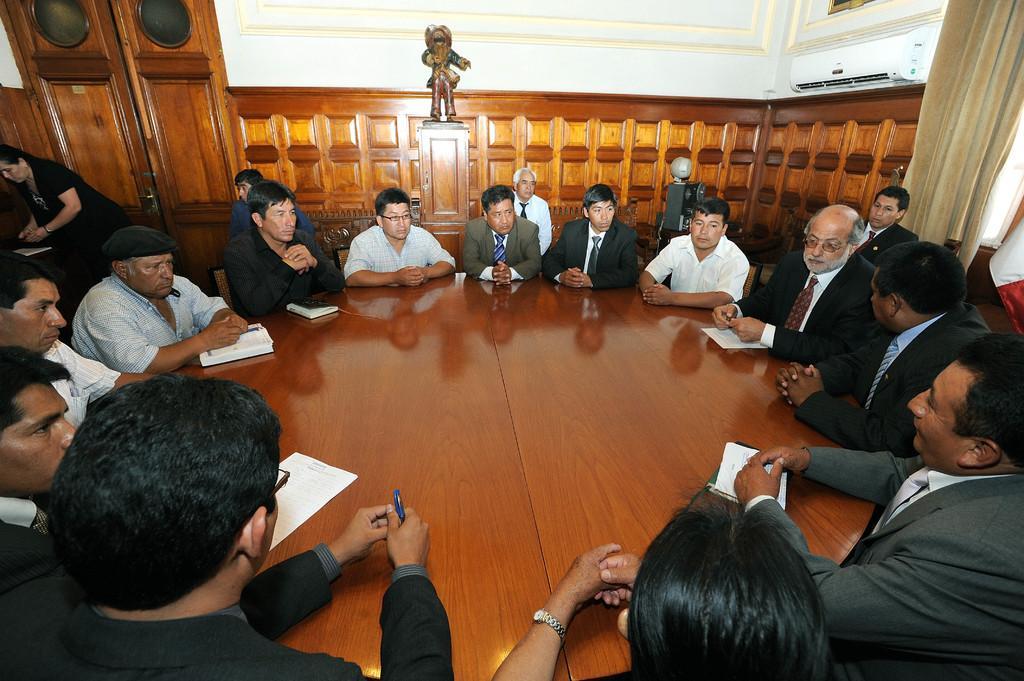Could you give a brief overview of what you see in this image? In this picture we can see a group of people sitting on the chair. We can see a person holding a pen in his hand visible in the bottom left. There are a few papers and books visible on a wooden table. We can see a woman standing and a few objects on the left side. There is a small statue on a wooden object. We can see a cloth in the top right. There is an air conditioner on the wall. We can see a door in the background. 